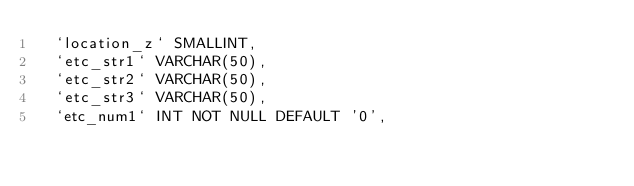<code> <loc_0><loc_0><loc_500><loc_500><_SQL_>	`location_z` SMALLINT,
	`etc_str1` VARCHAR(50),
	`etc_str2` VARCHAR(50),
	`etc_str3` VARCHAR(50),
	`etc_num1` INT NOT NULL DEFAULT '0',</code> 